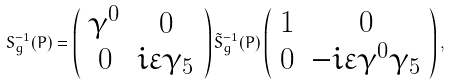Convert formula to latex. <formula><loc_0><loc_0><loc_500><loc_500>S _ { g } ^ { - 1 } ( P ) = \left ( \begin{array} { c c } \gamma ^ { 0 } & 0 \\ 0 & i \varepsilon \gamma _ { 5 } \end{array} \right ) \tilde { S } _ { g } ^ { - 1 } ( P ) \left ( \begin{array} { c c } 1 & 0 \\ 0 & - i \varepsilon \gamma ^ { 0 } \gamma _ { 5 } \end{array} \right ) ,</formula> 